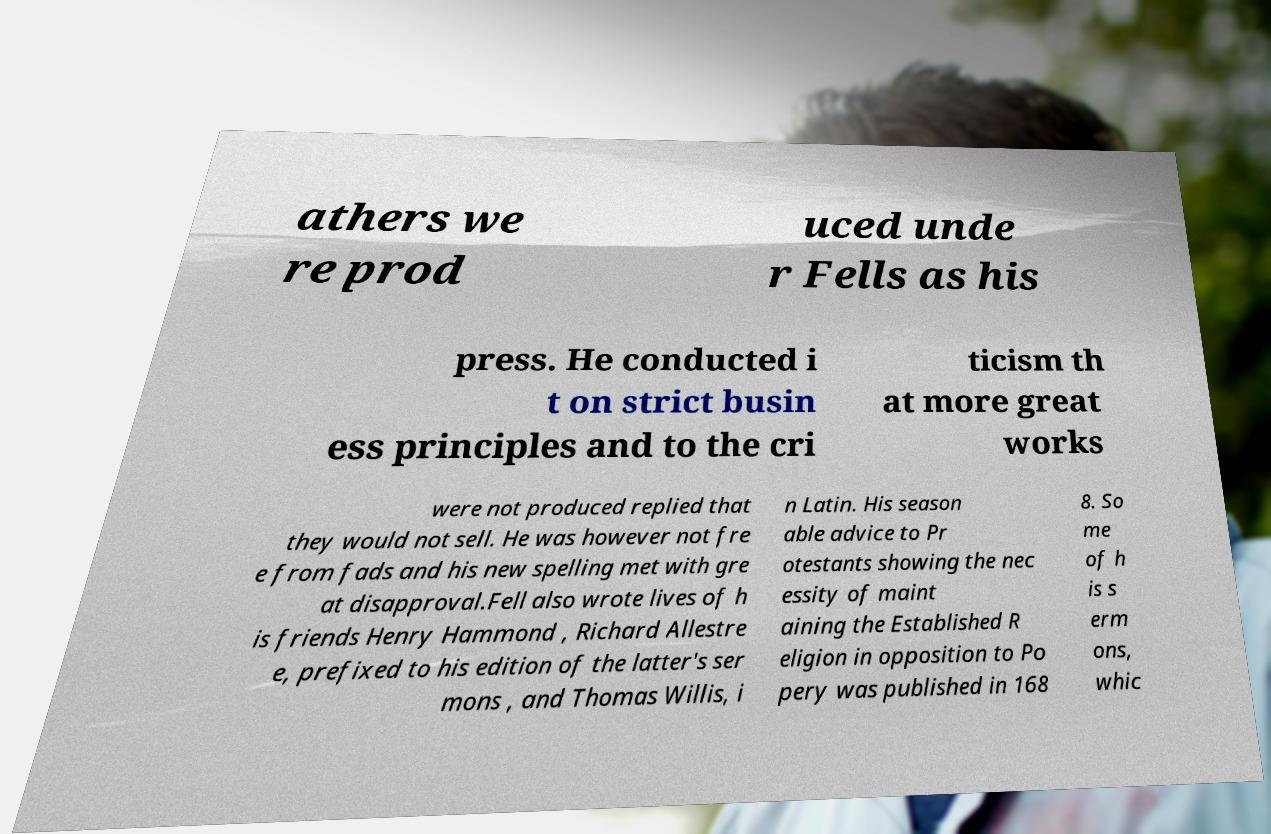Please read and relay the text visible in this image. What does it say? athers we re prod uced unde r Fells as his press. He conducted i t on strict busin ess principles and to the cri ticism th at more great works were not produced replied that they would not sell. He was however not fre e from fads and his new spelling met with gre at disapproval.Fell also wrote lives of h is friends Henry Hammond , Richard Allestre e, prefixed to his edition of the latter's ser mons , and Thomas Willis, i n Latin. His season able advice to Pr otestants showing the nec essity of maint aining the Established R eligion in opposition to Po pery was published in 168 8. So me of h is s erm ons, whic 